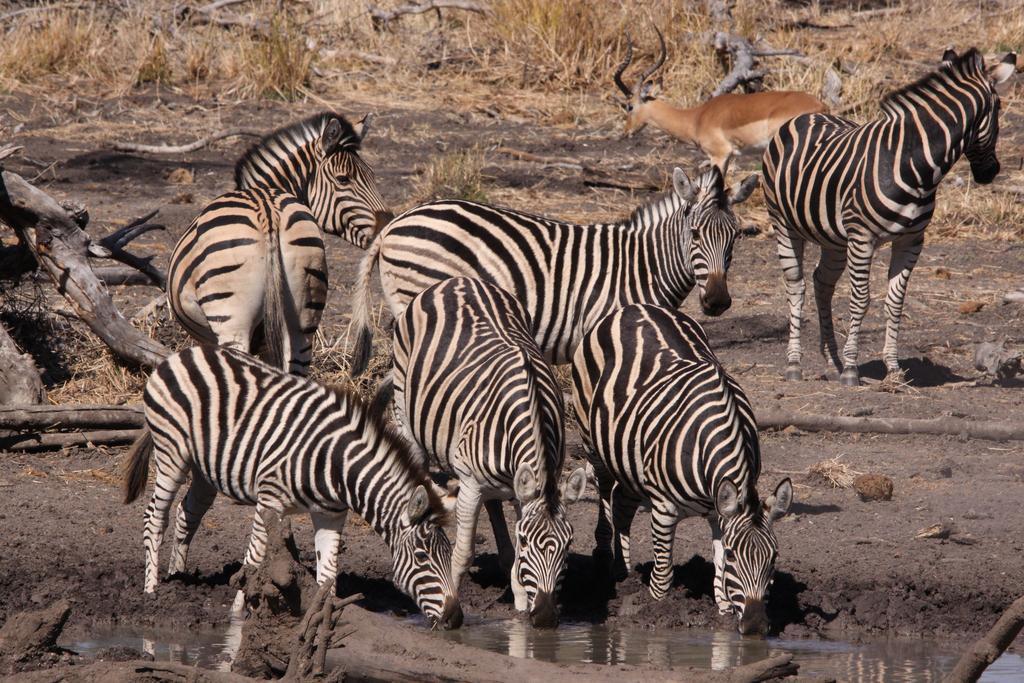Please provide a concise description of this image. In this picture we can see a group of zebras standing on the muddy ground. In the background, we can see a deer and dry grass. 